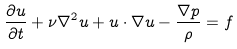Convert formula to latex. <formula><loc_0><loc_0><loc_500><loc_500>\frac { \partial { u } } { \partial t } + \nu \nabla ^ { 2 } { u } + { u } \cdot \nabla { u } - \frac { \nabla p } { \rho } = { f }</formula> 